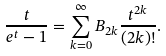Convert formula to latex. <formula><loc_0><loc_0><loc_500><loc_500>\frac { t } { e ^ { t } - 1 } = \sum _ { k = 0 } ^ { \infty } B _ { 2 k } \frac { t ^ { 2 k } } { ( 2 k ) ! } .</formula> 